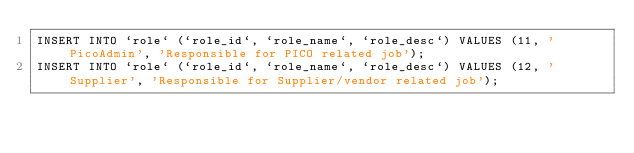Convert code to text. <code><loc_0><loc_0><loc_500><loc_500><_SQL_>INSERT INTO `role` (`role_id`, `role_name`, `role_desc`) VALUES (11, 'PicoAdmin', 'Responsible for PICO related job');
INSERT INTO `role` (`role_id`, `role_name`, `role_desc`) VALUES (12, 'Supplier', 'Responsible for Supplier/vendor related job');
 

</code> 